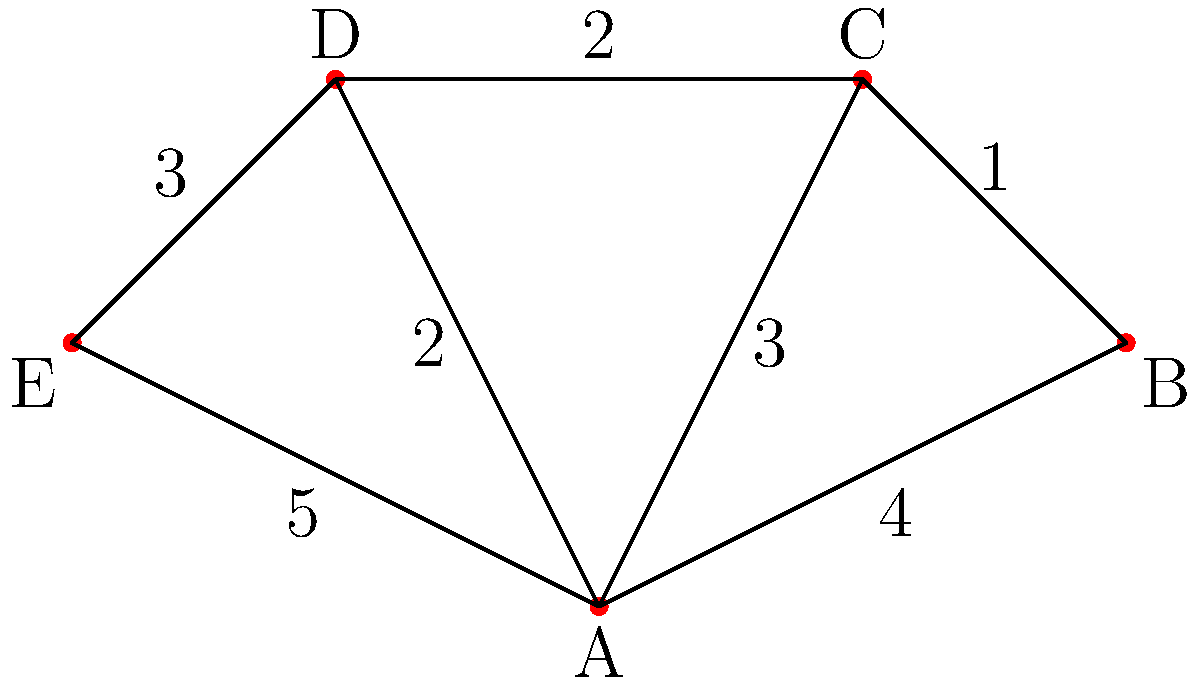In the planar graph representing a region's emergency equipment stations, vertices represent stations and edges represent routes between them, with weights indicating travel time in minutes. What is the minimum spanning tree weight, representing the optimal layout for efficient emergency response? To find the minimum spanning tree (MST) weight, we'll use Kruskal's algorithm:

1. Sort edges by weight:
   AB (4), AC (3), AD (2), AE (5), BC (1), CD (2), DE (3)

2. Add edges in order, skipping those that form cycles:
   a) BC (1) - Add
   b) AD (2) - Add
   c) CD (2) - Add
   d) AC (3) - Skip (forms cycle)
   e) DE (3) - Add

3. Stop when we have $n-1$ edges ($n$ = number of vertices):
   We have 4 edges (BC, AD, CD, DE), which is correct for 5 vertices.

4. Sum the weights of the selected edges:
   $1 + 2 + 2 + 3 = 8$

Therefore, the minimum spanning tree weight is 8 minutes.
Answer: 8 minutes 